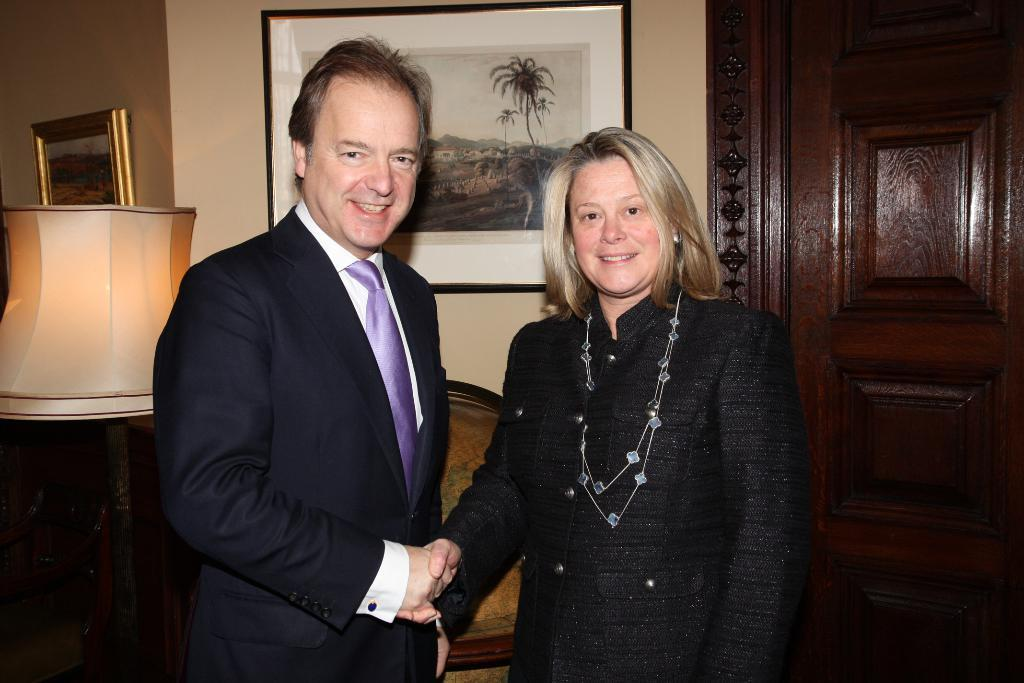How many people are in the image? There are two people in the image, a woman and a man. What are the woman and man wearing? They are both wearing suits. What are the woman and man doing in the image? They are watching something and shaking their hands. How are they feeling? They are both smiling. What can be seen in the background of the image? There is a wall with photo frames, a lamp, a door, and other objects visible. What type of ink is being used by the band in the image? There is no band present in the image, and therefore no ink can be associated with it. 